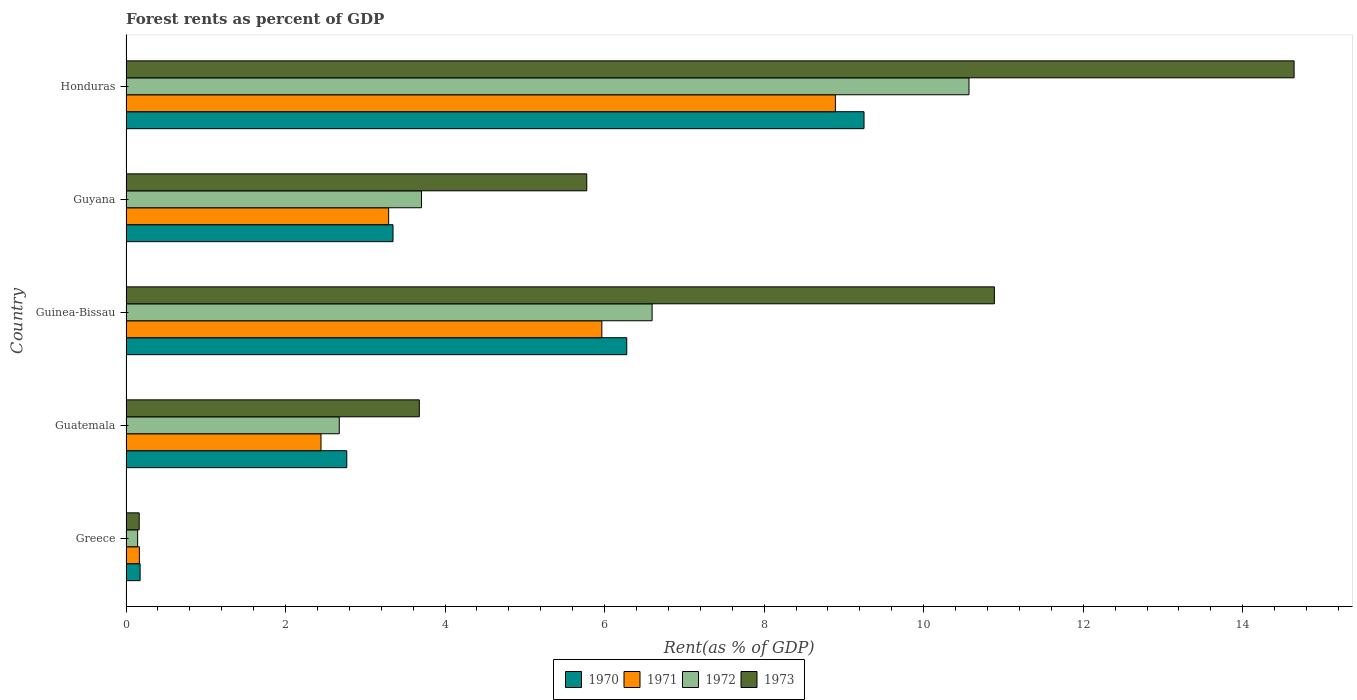How many different coloured bars are there?
Keep it short and to the point. 4. How many groups of bars are there?
Your answer should be very brief. 5. Are the number of bars on each tick of the Y-axis equal?
Your answer should be compact. Yes. How many bars are there on the 5th tick from the bottom?
Provide a succinct answer. 4. What is the label of the 4th group of bars from the top?
Your response must be concise. Guatemala. What is the forest rent in 1971 in Guatemala?
Keep it short and to the point. 2.44. Across all countries, what is the maximum forest rent in 1972?
Give a very brief answer. 10.57. Across all countries, what is the minimum forest rent in 1970?
Provide a succinct answer. 0.18. In which country was the forest rent in 1971 maximum?
Offer a terse response. Honduras. In which country was the forest rent in 1970 minimum?
Offer a terse response. Greece. What is the total forest rent in 1972 in the graph?
Give a very brief answer. 23.69. What is the difference between the forest rent in 1973 in Greece and that in Honduras?
Ensure brevity in your answer.  -14.48. What is the difference between the forest rent in 1970 in Guyana and the forest rent in 1972 in Guinea-Bissau?
Your response must be concise. -3.25. What is the average forest rent in 1972 per country?
Offer a very short reply. 4.74. What is the difference between the forest rent in 1972 and forest rent in 1973 in Guinea-Bissau?
Make the answer very short. -4.29. What is the ratio of the forest rent in 1973 in Guinea-Bissau to that in Guyana?
Provide a short and direct response. 1.88. Is the forest rent in 1970 in Greece less than that in Guinea-Bissau?
Your response must be concise. Yes. Is the difference between the forest rent in 1972 in Guyana and Honduras greater than the difference between the forest rent in 1973 in Guyana and Honduras?
Give a very brief answer. Yes. What is the difference between the highest and the second highest forest rent in 1972?
Offer a very short reply. 3.97. What is the difference between the highest and the lowest forest rent in 1970?
Give a very brief answer. 9.08. In how many countries, is the forest rent in 1973 greater than the average forest rent in 1973 taken over all countries?
Your answer should be compact. 2. Is it the case that in every country, the sum of the forest rent in 1971 and forest rent in 1970 is greater than the sum of forest rent in 1973 and forest rent in 1972?
Provide a succinct answer. No. What does the 3rd bar from the top in Guyana represents?
Your answer should be very brief. 1971. What does the 4th bar from the bottom in Greece represents?
Keep it short and to the point. 1973. Is it the case that in every country, the sum of the forest rent in 1970 and forest rent in 1971 is greater than the forest rent in 1973?
Provide a succinct answer. Yes. How many bars are there?
Ensure brevity in your answer.  20. Are all the bars in the graph horizontal?
Offer a terse response. Yes. How many countries are there in the graph?
Provide a succinct answer. 5. Are the values on the major ticks of X-axis written in scientific E-notation?
Your answer should be very brief. No. Does the graph contain any zero values?
Your answer should be compact. No. Does the graph contain grids?
Keep it short and to the point. No. Where does the legend appear in the graph?
Provide a succinct answer. Bottom center. How many legend labels are there?
Offer a terse response. 4. What is the title of the graph?
Offer a terse response. Forest rents as percent of GDP. What is the label or title of the X-axis?
Ensure brevity in your answer.  Rent(as % of GDP). What is the Rent(as % of GDP) of 1970 in Greece?
Give a very brief answer. 0.18. What is the Rent(as % of GDP) in 1971 in Greece?
Provide a succinct answer. 0.17. What is the Rent(as % of GDP) of 1972 in Greece?
Offer a very short reply. 0.15. What is the Rent(as % of GDP) in 1973 in Greece?
Offer a terse response. 0.17. What is the Rent(as % of GDP) in 1970 in Guatemala?
Make the answer very short. 2.77. What is the Rent(as % of GDP) in 1971 in Guatemala?
Your response must be concise. 2.44. What is the Rent(as % of GDP) in 1972 in Guatemala?
Your response must be concise. 2.67. What is the Rent(as % of GDP) of 1973 in Guatemala?
Make the answer very short. 3.68. What is the Rent(as % of GDP) in 1970 in Guinea-Bissau?
Provide a short and direct response. 6.28. What is the Rent(as % of GDP) of 1971 in Guinea-Bissau?
Your response must be concise. 5.97. What is the Rent(as % of GDP) in 1972 in Guinea-Bissau?
Offer a terse response. 6.6. What is the Rent(as % of GDP) in 1973 in Guinea-Bissau?
Ensure brevity in your answer.  10.89. What is the Rent(as % of GDP) of 1970 in Guyana?
Your answer should be compact. 3.35. What is the Rent(as % of GDP) in 1971 in Guyana?
Offer a very short reply. 3.29. What is the Rent(as % of GDP) in 1972 in Guyana?
Provide a succinct answer. 3.7. What is the Rent(as % of GDP) of 1973 in Guyana?
Make the answer very short. 5.78. What is the Rent(as % of GDP) in 1970 in Honduras?
Keep it short and to the point. 9.25. What is the Rent(as % of GDP) of 1971 in Honduras?
Your answer should be very brief. 8.89. What is the Rent(as % of GDP) of 1972 in Honduras?
Make the answer very short. 10.57. What is the Rent(as % of GDP) of 1973 in Honduras?
Your answer should be very brief. 14.64. Across all countries, what is the maximum Rent(as % of GDP) in 1970?
Offer a very short reply. 9.25. Across all countries, what is the maximum Rent(as % of GDP) of 1971?
Your response must be concise. 8.89. Across all countries, what is the maximum Rent(as % of GDP) of 1972?
Ensure brevity in your answer.  10.57. Across all countries, what is the maximum Rent(as % of GDP) in 1973?
Provide a succinct answer. 14.64. Across all countries, what is the minimum Rent(as % of GDP) of 1970?
Provide a short and direct response. 0.18. Across all countries, what is the minimum Rent(as % of GDP) of 1971?
Your answer should be very brief. 0.17. Across all countries, what is the minimum Rent(as % of GDP) in 1972?
Your response must be concise. 0.15. Across all countries, what is the minimum Rent(as % of GDP) in 1973?
Your response must be concise. 0.17. What is the total Rent(as % of GDP) of 1970 in the graph?
Provide a short and direct response. 21.82. What is the total Rent(as % of GDP) in 1971 in the graph?
Make the answer very short. 20.76. What is the total Rent(as % of GDP) in 1972 in the graph?
Offer a very short reply. 23.69. What is the total Rent(as % of GDP) of 1973 in the graph?
Your response must be concise. 35.15. What is the difference between the Rent(as % of GDP) of 1970 in Greece and that in Guatemala?
Provide a succinct answer. -2.59. What is the difference between the Rent(as % of GDP) of 1971 in Greece and that in Guatemala?
Your answer should be compact. -2.28. What is the difference between the Rent(as % of GDP) in 1972 in Greece and that in Guatemala?
Provide a succinct answer. -2.53. What is the difference between the Rent(as % of GDP) in 1973 in Greece and that in Guatemala?
Offer a terse response. -3.51. What is the difference between the Rent(as % of GDP) in 1970 in Greece and that in Guinea-Bissau?
Make the answer very short. -6.1. What is the difference between the Rent(as % of GDP) of 1971 in Greece and that in Guinea-Bissau?
Give a very brief answer. -5.8. What is the difference between the Rent(as % of GDP) in 1972 in Greece and that in Guinea-Bissau?
Keep it short and to the point. -6.45. What is the difference between the Rent(as % of GDP) of 1973 in Greece and that in Guinea-Bissau?
Offer a terse response. -10.72. What is the difference between the Rent(as % of GDP) in 1970 in Greece and that in Guyana?
Make the answer very short. -3.17. What is the difference between the Rent(as % of GDP) in 1971 in Greece and that in Guyana?
Your answer should be very brief. -3.13. What is the difference between the Rent(as % of GDP) of 1972 in Greece and that in Guyana?
Provide a succinct answer. -3.56. What is the difference between the Rent(as % of GDP) of 1973 in Greece and that in Guyana?
Provide a succinct answer. -5.61. What is the difference between the Rent(as % of GDP) in 1970 in Greece and that in Honduras?
Your answer should be very brief. -9.08. What is the difference between the Rent(as % of GDP) of 1971 in Greece and that in Honduras?
Make the answer very short. -8.73. What is the difference between the Rent(as % of GDP) of 1972 in Greece and that in Honduras?
Give a very brief answer. -10.42. What is the difference between the Rent(as % of GDP) of 1973 in Greece and that in Honduras?
Ensure brevity in your answer.  -14.48. What is the difference between the Rent(as % of GDP) of 1970 in Guatemala and that in Guinea-Bissau?
Make the answer very short. -3.51. What is the difference between the Rent(as % of GDP) of 1971 in Guatemala and that in Guinea-Bissau?
Your answer should be compact. -3.52. What is the difference between the Rent(as % of GDP) of 1972 in Guatemala and that in Guinea-Bissau?
Provide a succinct answer. -3.92. What is the difference between the Rent(as % of GDP) of 1973 in Guatemala and that in Guinea-Bissau?
Provide a succinct answer. -7.21. What is the difference between the Rent(as % of GDP) of 1970 in Guatemala and that in Guyana?
Give a very brief answer. -0.58. What is the difference between the Rent(as % of GDP) in 1971 in Guatemala and that in Guyana?
Provide a short and direct response. -0.85. What is the difference between the Rent(as % of GDP) of 1972 in Guatemala and that in Guyana?
Your answer should be very brief. -1.03. What is the difference between the Rent(as % of GDP) in 1973 in Guatemala and that in Guyana?
Provide a short and direct response. -2.1. What is the difference between the Rent(as % of GDP) in 1970 in Guatemala and that in Honduras?
Your answer should be compact. -6.48. What is the difference between the Rent(as % of GDP) of 1971 in Guatemala and that in Honduras?
Provide a succinct answer. -6.45. What is the difference between the Rent(as % of GDP) in 1972 in Guatemala and that in Honduras?
Make the answer very short. -7.89. What is the difference between the Rent(as % of GDP) in 1973 in Guatemala and that in Honduras?
Provide a succinct answer. -10.97. What is the difference between the Rent(as % of GDP) of 1970 in Guinea-Bissau and that in Guyana?
Give a very brief answer. 2.93. What is the difference between the Rent(as % of GDP) of 1971 in Guinea-Bissau and that in Guyana?
Provide a short and direct response. 2.67. What is the difference between the Rent(as % of GDP) of 1972 in Guinea-Bissau and that in Guyana?
Make the answer very short. 2.89. What is the difference between the Rent(as % of GDP) in 1973 in Guinea-Bissau and that in Guyana?
Make the answer very short. 5.11. What is the difference between the Rent(as % of GDP) of 1970 in Guinea-Bissau and that in Honduras?
Your answer should be very brief. -2.97. What is the difference between the Rent(as % of GDP) of 1971 in Guinea-Bissau and that in Honduras?
Offer a very short reply. -2.93. What is the difference between the Rent(as % of GDP) of 1972 in Guinea-Bissau and that in Honduras?
Provide a succinct answer. -3.97. What is the difference between the Rent(as % of GDP) of 1973 in Guinea-Bissau and that in Honduras?
Keep it short and to the point. -3.76. What is the difference between the Rent(as % of GDP) of 1970 in Guyana and that in Honduras?
Your answer should be very brief. -5.9. What is the difference between the Rent(as % of GDP) of 1971 in Guyana and that in Honduras?
Your answer should be very brief. -5.6. What is the difference between the Rent(as % of GDP) in 1972 in Guyana and that in Honduras?
Offer a terse response. -6.86. What is the difference between the Rent(as % of GDP) in 1973 in Guyana and that in Honduras?
Provide a short and direct response. -8.87. What is the difference between the Rent(as % of GDP) of 1970 in Greece and the Rent(as % of GDP) of 1971 in Guatemala?
Provide a succinct answer. -2.27. What is the difference between the Rent(as % of GDP) of 1970 in Greece and the Rent(as % of GDP) of 1972 in Guatemala?
Offer a terse response. -2.5. What is the difference between the Rent(as % of GDP) in 1970 in Greece and the Rent(as % of GDP) in 1973 in Guatemala?
Provide a succinct answer. -3.5. What is the difference between the Rent(as % of GDP) of 1971 in Greece and the Rent(as % of GDP) of 1972 in Guatemala?
Provide a short and direct response. -2.51. What is the difference between the Rent(as % of GDP) in 1971 in Greece and the Rent(as % of GDP) in 1973 in Guatemala?
Keep it short and to the point. -3.51. What is the difference between the Rent(as % of GDP) of 1972 in Greece and the Rent(as % of GDP) of 1973 in Guatemala?
Provide a succinct answer. -3.53. What is the difference between the Rent(as % of GDP) of 1970 in Greece and the Rent(as % of GDP) of 1971 in Guinea-Bissau?
Offer a very short reply. -5.79. What is the difference between the Rent(as % of GDP) of 1970 in Greece and the Rent(as % of GDP) of 1972 in Guinea-Bissau?
Offer a very short reply. -6.42. What is the difference between the Rent(as % of GDP) of 1970 in Greece and the Rent(as % of GDP) of 1973 in Guinea-Bissau?
Your response must be concise. -10.71. What is the difference between the Rent(as % of GDP) of 1971 in Greece and the Rent(as % of GDP) of 1972 in Guinea-Bissau?
Your answer should be very brief. -6.43. What is the difference between the Rent(as % of GDP) of 1971 in Greece and the Rent(as % of GDP) of 1973 in Guinea-Bissau?
Your answer should be compact. -10.72. What is the difference between the Rent(as % of GDP) of 1972 in Greece and the Rent(as % of GDP) of 1973 in Guinea-Bissau?
Keep it short and to the point. -10.74. What is the difference between the Rent(as % of GDP) of 1970 in Greece and the Rent(as % of GDP) of 1971 in Guyana?
Your answer should be very brief. -3.12. What is the difference between the Rent(as % of GDP) in 1970 in Greece and the Rent(as % of GDP) in 1972 in Guyana?
Offer a very short reply. -3.53. What is the difference between the Rent(as % of GDP) of 1970 in Greece and the Rent(as % of GDP) of 1973 in Guyana?
Offer a terse response. -5.6. What is the difference between the Rent(as % of GDP) of 1971 in Greece and the Rent(as % of GDP) of 1972 in Guyana?
Ensure brevity in your answer.  -3.54. What is the difference between the Rent(as % of GDP) of 1971 in Greece and the Rent(as % of GDP) of 1973 in Guyana?
Offer a very short reply. -5.61. What is the difference between the Rent(as % of GDP) in 1972 in Greece and the Rent(as % of GDP) in 1973 in Guyana?
Ensure brevity in your answer.  -5.63. What is the difference between the Rent(as % of GDP) in 1970 in Greece and the Rent(as % of GDP) in 1971 in Honduras?
Your response must be concise. -8.72. What is the difference between the Rent(as % of GDP) in 1970 in Greece and the Rent(as % of GDP) in 1972 in Honduras?
Provide a short and direct response. -10.39. What is the difference between the Rent(as % of GDP) of 1970 in Greece and the Rent(as % of GDP) of 1973 in Honduras?
Give a very brief answer. -14.47. What is the difference between the Rent(as % of GDP) of 1971 in Greece and the Rent(as % of GDP) of 1972 in Honduras?
Your response must be concise. -10.4. What is the difference between the Rent(as % of GDP) in 1971 in Greece and the Rent(as % of GDP) in 1973 in Honduras?
Offer a terse response. -14.48. What is the difference between the Rent(as % of GDP) in 1972 in Greece and the Rent(as % of GDP) in 1973 in Honduras?
Keep it short and to the point. -14.5. What is the difference between the Rent(as % of GDP) of 1970 in Guatemala and the Rent(as % of GDP) of 1971 in Guinea-Bissau?
Ensure brevity in your answer.  -3.2. What is the difference between the Rent(as % of GDP) in 1970 in Guatemala and the Rent(as % of GDP) in 1972 in Guinea-Bissau?
Make the answer very short. -3.83. What is the difference between the Rent(as % of GDP) in 1970 in Guatemala and the Rent(as % of GDP) in 1973 in Guinea-Bissau?
Your answer should be compact. -8.12. What is the difference between the Rent(as % of GDP) of 1971 in Guatemala and the Rent(as % of GDP) of 1972 in Guinea-Bissau?
Ensure brevity in your answer.  -4.15. What is the difference between the Rent(as % of GDP) of 1971 in Guatemala and the Rent(as % of GDP) of 1973 in Guinea-Bissau?
Your answer should be very brief. -8.44. What is the difference between the Rent(as % of GDP) of 1972 in Guatemala and the Rent(as % of GDP) of 1973 in Guinea-Bissau?
Your response must be concise. -8.21. What is the difference between the Rent(as % of GDP) in 1970 in Guatemala and the Rent(as % of GDP) in 1971 in Guyana?
Offer a terse response. -0.53. What is the difference between the Rent(as % of GDP) in 1970 in Guatemala and the Rent(as % of GDP) in 1972 in Guyana?
Your answer should be compact. -0.94. What is the difference between the Rent(as % of GDP) of 1970 in Guatemala and the Rent(as % of GDP) of 1973 in Guyana?
Give a very brief answer. -3.01. What is the difference between the Rent(as % of GDP) in 1971 in Guatemala and the Rent(as % of GDP) in 1972 in Guyana?
Your answer should be compact. -1.26. What is the difference between the Rent(as % of GDP) in 1971 in Guatemala and the Rent(as % of GDP) in 1973 in Guyana?
Offer a very short reply. -3.33. What is the difference between the Rent(as % of GDP) of 1972 in Guatemala and the Rent(as % of GDP) of 1973 in Guyana?
Offer a very short reply. -3.1. What is the difference between the Rent(as % of GDP) of 1970 in Guatemala and the Rent(as % of GDP) of 1971 in Honduras?
Provide a short and direct response. -6.13. What is the difference between the Rent(as % of GDP) of 1970 in Guatemala and the Rent(as % of GDP) of 1972 in Honduras?
Your answer should be compact. -7.8. What is the difference between the Rent(as % of GDP) in 1970 in Guatemala and the Rent(as % of GDP) in 1973 in Honduras?
Provide a succinct answer. -11.88. What is the difference between the Rent(as % of GDP) of 1971 in Guatemala and the Rent(as % of GDP) of 1972 in Honduras?
Provide a short and direct response. -8.12. What is the difference between the Rent(as % of GDP) in 1971 in Guatemala and the Rent(as % of GDP) in 1973 in Honduras?
Give a very brief answer. -12.2. What is the difference between the Rent(as % of GDP) of 1972 in Guatemala and the Rent(as % of GDP) of 1973 in Honduras?
Your answer should be compact. -11.97. What is the difference between the Rent(as % of GDP) of 1970 in Guinea-Bissau and the Rent(as % of GDP) of 1971 in Guyana?
Provide a succinct answer. 2.99. What is the difference between the Rent(as % of GDP) of 1970 in Guinea-Bissau and the Rent(as % of GDP) of 1972 in Guyana?
Provide a short and direct response. 2.57. What is the difference between the Rent(as % of GDP) in 1970 in Guinea-Bissau and the Rent(as % of GDP) in 1973 in Guyana?
Provide a short and direct response. 0.5. What is the difference between the Rent(as % of GDP) of 1971 in Guinea-Bissau and the Rent(as % of GDP) of 1972 in Guyana?
Make the answer very short. 2.26. What is the difference between the Rent(as % of GDP) in 1971 in Guinea-Bissau and the Rent(as % of GDP) in 1973 in Guyana?
Give a very brief answer. 0.19. What is the difference between the Rent(as % of GDP) in 1972 in Guinea-Bissau and the Rent(as % of GDP) in 1973 in Guyana?
Offer a terse response. 0.82. What is the difference between the Rent(as % of GDP) in 1970 in Guinea-Bissau and the Rent(as % of GDP) in 1971 in Honduras?
Make the answer very short. -2.62. What is the difference between the Rent(as % of GDP) in 1970 in Guinea-Bissau and the Rent(as % of GDP) in 1972 in Honduras?
Ensure brevity in your answer.  -4.29. What is the difference between the Rent(as % of GDP) of 1970 in Guinea-Bissau and the Rent(as % of GDP) of 1973 in Honduras?
Provide a succinct answer. -8.37. What is the difference between the Rent(as % of GDP) in 1971 in Guinea-Bissau and the Rent(as % of GDP) in 1972 in Honduras?
Ensure brevity in your answer.  -4.6. What is the difference between the Rent(as % of GDP) in 1971 in Guinea-Bissau and the Rent(as % of GDP) in 1973 in Honduras?
Make the answer very short. -8.68. What is the difference between the Rent(as % of GDP) in 1972 in Guinea-Bissau and the Rent(as % of GDP) in 1973 in Honduras?
Offer a very short reply. -8.05. What is the difference between the Rent(as % of GDP) in 1970 in Guyana and the Rent(as % of GDP) in 1971 in Honduras?
Give a very brief answer. -5.55. What is the difference between the Rent(as % of GDP) of 1970 in Guyana and the Rent(as % of GDP) of 1972 in Honduras?
Offer a very short reply. -7.22. What is the difference between the Rent(as % of GDP) of 1970 in Guyana and the Rent(as % of GDP) of 1973 in Honduras?
Ensure brevity in your answer.  -11.3. What is the difference between the Rent(as % of GDP) of 1971 in Guyana and the Rent(as % of GDP) of 1972 in Honduras?
Ensure brevity in your answer.  -7.28. What is the difference between the Rent(as % of GDP) in 1971 in Guyana and the Rent(as % of GDP) in 1973 in Honduras?
Your answer should be very brief. -11.35. What is the difference between the Rent(as % of GDP) in 1972 in Guyana and the Rent(as % of GDP) in 1973 in Honduras?
Provide a succinct answer. -10.94. What is the average Rent(as % of GDP) of 1970 per country?
Your response must be concise. 4.36. What is the average Rent(as % of GDP) in 1971 per country?
Keep it short and to the point. 4.15. What is the average Rent(as % of GDP) of 1972 per country?
Ensure brevity in your answer.  4.74. What is the average Rent(as % of GDP) in 1973 per country?
Ensure brevity in your answer.  7.03. What is the difference between the Rent(as % of GDP) of 1970 and Rent(as % of GDP) of 1971 in Greece?
Offer a very short reply. 0.01. What is the difference between the Rent(as % of GDP) of 1970 and Rent(as % of GDP) of 1972 in Greece?
Give a very brief answer. 0.03. What is the difference between the Rent(as % of GDP) of 1970 and Rent(as % of GDP) of 1973 in Greece?
Your response must be concise. 0.01. What is the difference between the Rent(as % of GDP) in 1971 and Rent(as % of GDP) in 1972 in Greece?
Your answer should be compact. 0.02. What is the difference between the Rent(as % of GDP) in 1971 and Rent(as % of GDP) in 1973 in Greece?
Your response must be concise. 0. What is the difference between the Rent(as % of GDP) of 1972 and Rent(as % of GDP) of 1973 in Greece?
Ensure brevity in your answer.  -0.02. What is the difference between the Rent(as % of GDP) in 1970 and Rent(as % of GDP) in 1971 in Guatemala?
Ensure brevity in your answer.  0.32. What is the difference between the Rent(as % of GDP) in 1970 and Rent(as % of GDP) in 1972 in Guatemala?
Your answer should be very brief. 0.09. What is the difference between the Rent(as % of GDP) in 1970 and Rent(as % of GDP) in 1973 in Guatemala?
Make the answer very short. -0.91. What is the difference between the Rent(as % of GDP) in 1971 and Rent(as % of GDP) in 1972 in Guatemala?
Give a very brief answer. -0.23. What is the difference between the Rent(as % of GDP) in 1971 and Rent(as % of GDP) in 1973 in Guatemala?
Your answer should be very brief. -1.23. What is the difference between the Rent(as % of GDP) in 1972 and Rent(as % of GDP) in 1973 in Guatemala?
Your answer should be compact. -1. What is the difference between the Rent(as % of GDP) in 1970 and Rent(as % of GDP) in 1971 in Guinea-Bissau?
Provide a short and direct response. 0.31. What is the difference between the Rent(as % of GDP) in 1970 and Rent(as % of GDP) in 1972 in Guinea-Bissau?
Provide a short and direct response. -0.32. What is the difference between the Rent(as % of GDP) in 1970 and Rent(as % of GDP) in 1973 in Guinea-Bissau?
Make the answer very short. -4.61. What is the difference between the Rent(as % of GDP) of 1971 and Rent(as % of GDP) of 1972 in Guinea-Bissau?
Your answer should be compact. -0.63. What is the difference between the Rent(as % of GDP) of 1971 and Rent(as % of GDP) of 1973 in Guinea-Bissau?
Give a very brief answer. -4.92. What is the difference between the Rent(as % of GDP) of 1972 and Rent(as % of GDP) of 1973 in Guinea-Bissau?
Keep it short and to the point. -4.29. What is the difference between the Rent(as % of GDP) in 1970 and Rent(as % of GDP) in 1971 in Guyana?
Your answer should be compact. 0.05. What is the difference between the Rent(as % of GDP) of 1970 and Rent(as % of GDP) of 1972 in Guyana?
Give a very brief answer. -0.36. What is the difference between the Rent(as % of GDP) of 1970 and Rent(as % of GDP) of 1973 in Guyana?
Give a very brief answer. -2.43. What is the difference between the Rent(as % of GDP) in 1971 and Rent(as % of GDP) in 1972 in Guyana?
Your answer should be very brief. -0.41. What is the difference between the Rent(as % of GDP) in 1971 and Rent(as % of GDP) in 1973 in Guyana?
Keep it short and to the point. -2.48. What is the difference between the Rent(as % of GDP) in 1972 and Rent(as % of GDP) in 1973 in Guyana?
Provide a short and direct response. -2.07. What is the difference between the Rent(as % of GDP) in 1970 and Rent(as % of GDP) in 1971 in Honduras?
Give a very brief answer. 0.36. What is the difference between the Rent(as % of GDP) of 1970 and Rent(as % of GDP) of 1972 in Honduras?
Your answer should be very brief. -1.32. What is the difference between the Rent(as % of GDP) of 1970 and Rent(as % of GDP) of 1973 in Honduras?
Keep it short and to the point. -5.39. What is the difference between the Rent(as % of GDP) of 1971 and Rent(as % of GDP) of 1972 in Honduras?
Provide a short and direct response. -1.67. What is the difference between the Rent(as % of GDP) in 1971 and Rent(as % of GDP) in 1973 in Honduras?
Offer a terse response. -5.75. What is the difference between the Rent(as % of GDP) of 1972 and Rent(as % of GDP) of 1973 in Honduras?
Provide a succinct answer. -4.08. What is the ratio of the Rent(as % of GDP) of 1970 in Greece to that in Guatemala?
Provide a short and direct response. 0.06. What is the ratio of the Rent(as % of GDP) of 1971 in Greece to that in Guatemala?
Make the answer very short. 0.07. What is the ratio of the Rent(as % of GDP) of 1972 in Greece to that in Guatemala?
Provide a short and direct response. 0.05. What is the ratio of the Rent(as % of GDP) in 1973 in Greece to that in Guatemala?
Ensure brevity in your answer.  0.04. What is the ratio of the Rent(as % of GDP) in 1970 in Greece to that in Guinea-Bissau?
Give a very brief answer. 0.03. What is the ratio of the Rent(as % of GDP) in 1971 in Greece to that in Guinea-Bissau?
Provide a succinct answer. 0.03. What is the ratio of the Rent(as % of GDP) of 1972 in Greece to that in Guinea-Bissau?
Provide a short and direct response. 0.02. What is the ratio of the Rent(as % of GDP) in 1973 in Greece to that in Guinea-Bissau?
Your answer should be compact. 0.02. What is the ratio of the Rent(as % of GDP) of 1970 in Greece to that in Guyana?
Keep it short and to the point. 0.05. What is the ratio of the Rent(as % of GDP) in 1971 in Greece to that in Guyana?
Offer a terse response. 0.05. What is the ratio of the Rent(as % of GDP) in 1972 in Greece to that in Guyana?
Offer a very short reply. 0.04. What is the ratio of the Rent(as % of GDP) of 1973 in Greece to that in Guyana?
Offer a very short reply. 0.03. What is the ratio of the Rent(as % of GDP) in 1970 in Greece to that in Honduras?
Provide a succinct answer. 0.02. What is the ratio of the Rent(as % of GDP) in 1971 in Greece to that in Honduras?
Offer a terse response. 0.02. What is the ratio of the Rent(as % of GDP) of 1972 in Greece to that in Honduras?
Give a very brief answer. 0.01. What is the ratio of the Rent(as % of GDP) of 1973 in Greece to that in Honduras?
Provide a short and direct response. 0.01. What is the ratio of the Rent(as % of GDP) of 1970 in Guatemala to that in Guinea-Bissau?
Make the answer very short. 0.44. What is the ratio of the Rent(as % of GDP) of 1971 in Guatemala to that in Guinea-Bissau?
Provide a short and direct response. 0.41. What is the ratio of the Rent(as % of GDP) in 1972 in Guatemala to that in Guinea-Bissau?
Provide a short and direct response. 0.41. What is the ratio of the Rent(as % of GDP) of 1973 in Guatemala to that in Guinea-Bissau?
Your answer should be compact. 0.34. What is the ratio of the Rent(as % of GDP) in 1970 in Guatemala to that in Guyana?
Provide a succinct answer. 0.83. What is the ratio of the Rent(as % of GDP) of 1971 in Guatemala to that in Guyana?
Offer a terse response. 0.74. What is the ratio of the Rent(as % of GDP) in 1972 in Guatemala to that in Guyana?
Keep it short and to the point. 0.72. What is the ratio of the Rent(as % of GDP) in 1973 in Guatemala to that in Guyana?
Provide a short and direct response. 0.64. What is the ratio of the Rent(as % of GDP) in 1970 in Guatemala to that in Honduras?
Your response must be concise. 0.3. What is the ratio of the Rent(as % of GDP) in 1971 in Guatemala to that in Honduras?
Offer a very short reply. 0.27. What is the ratio of the Rent(as % of GDP) in 1972 in Guatemala to that in Honduras?
Make the answer very short. 0.25. What is the ratio of the Rent(as % of GDP) in 1973 in Guatemala to that in Honduras?
Offer a very short reply. 0.25. What is the ratio of the Rent(as % of GDP) in 1970 in Guinea-Bissau to that in Guyana?
Keep it short and to the point. 1.88. What is the ratio of the Rent(as % of GDP) of 1971 in Guinea-Bissau to that in Guyana?
Your answer should be compact. 1.81. What is the ratio of the Rent(as % of GDP) of 1972 in Guinea-Bissau to that in Guyana?
Give a very brief answer. 1.78. What is the ratio of the Rent(as % of GDP) of 1973 in Guinea-Bissau to that in Guyana?
Offer a very short reply. 1.88. What is the ratio of the Rent(as % of GDP) in 1970 in Guinea-Bissau to that in Honduras?
Your answer should be compact. 0.68. What is the ratio of the Rent(as % of GDP) of 1971 in Guinea-Bissau to that in Honduras?
Your answer should be very brief. 0.67. What is the ratio of the Rent(as % of GDP) in 1972 in Guinea-Bissau to that in Honduras?
Your response must be concise. 0.62. What is the ratio of the Rent(as % of GDP) in 1973 in Guinea-Bissau to that in Honduras?
Give a very brief answer. 0.74. What is the ratio of the Rent(as % of GDP) of 1970 in Guyana to that in Honduras?
Your answer should be compact. 0.36. What is the ratio of the Rent(as % of GDP) in 1971 in Guyana to that in Honduras?
Your answer should be very brief. 0.37. What is the ratio of the Rent(as % of GDP) of 1972 in Guyana to that in Honduras?
Ensure brevity in your answer.  0.35. What is the ratio of the Rent(as % of GDP) in 1973 in Guyana to that in Honduras?
Your answer should be compact. 0.39. What is the difference between the highest and the second highest Rent(as % of GDP) in 1970?
Offer a very short reply. 2.97. What is the difference between the highest and the second highest Rent(as % of GDP) of 1971?
Offer a very short reply. 2.93. What is the difference between the highest and the second highest Rent(as % of GDP) in 1972?
Provide a succinct answer. 3.97. What is the difference between the highest and the second highest Rent(as % of GDP) in 1973?
Ensure brevity in your answer.  3.76. What is the difference between the highest and the lowest Rent(as % of GDP) of 1970?
Your answer should be compact. 9.08. What is the difference between the highest and the lowest Rent(as % of GDP) of 1971?
Give a very brief answer. 8.73. What is the difference between the highest and the lowest Rent(as % of GDP) of 1972?
Your answer should be compact. 10.42. What is the difference between the highest and the lowest Rent(as % of GDP) in 1973?
Your answer should be compact. 14.48. 